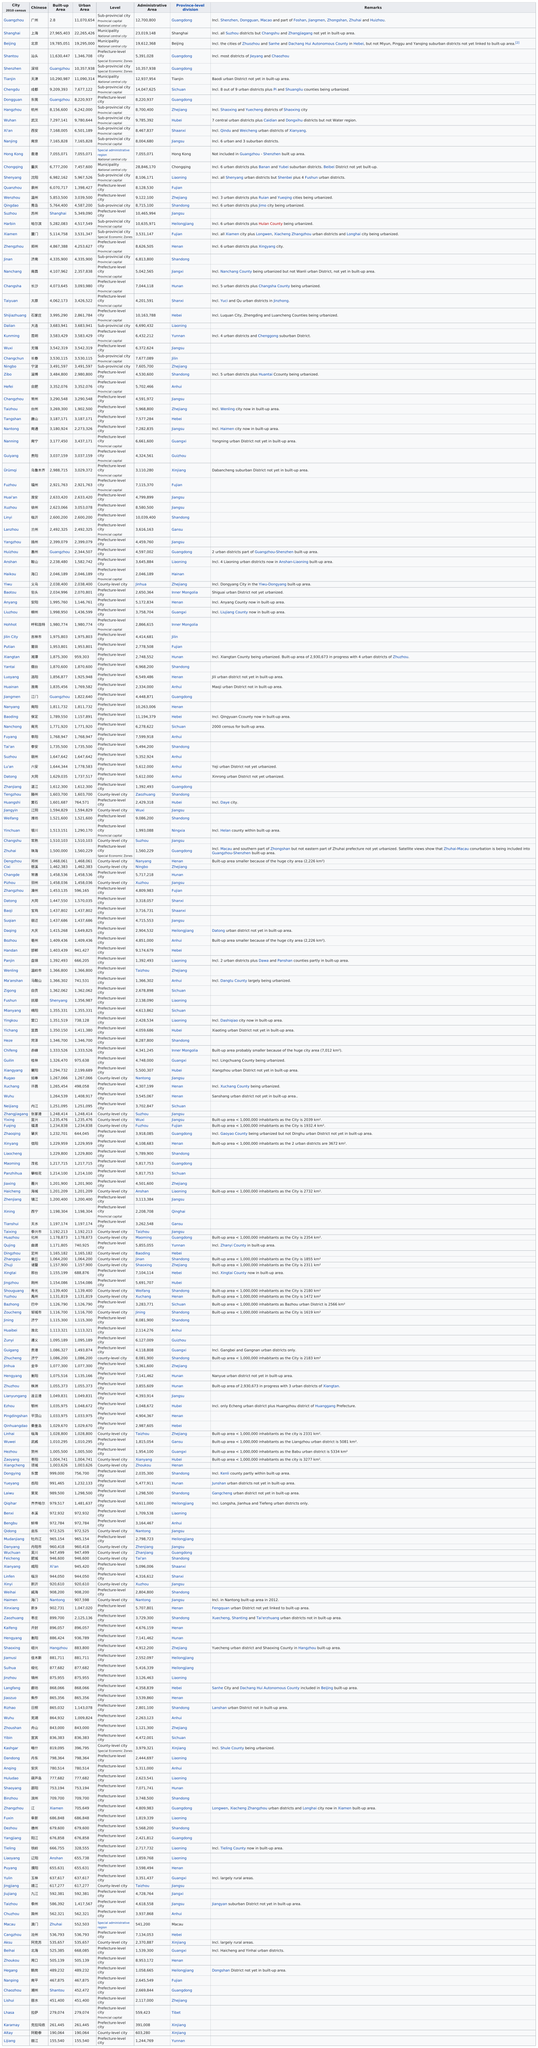Mention a couple of crucial points in this snapshot. Shanghai has the largest number of people among the cities of Beijing and Shanghai. According to the latest data, approximately 4,867,388 people live within the built up area of Zhengzhou. Guangzhou has more in its built-up area than any other city. Shenzhen, a city that does not have any comments listed, is known for... Beijing has a larger population in its urban area than Lijiang, with 19,139,460 inhabitants compared to Lijiang's 441,841. 